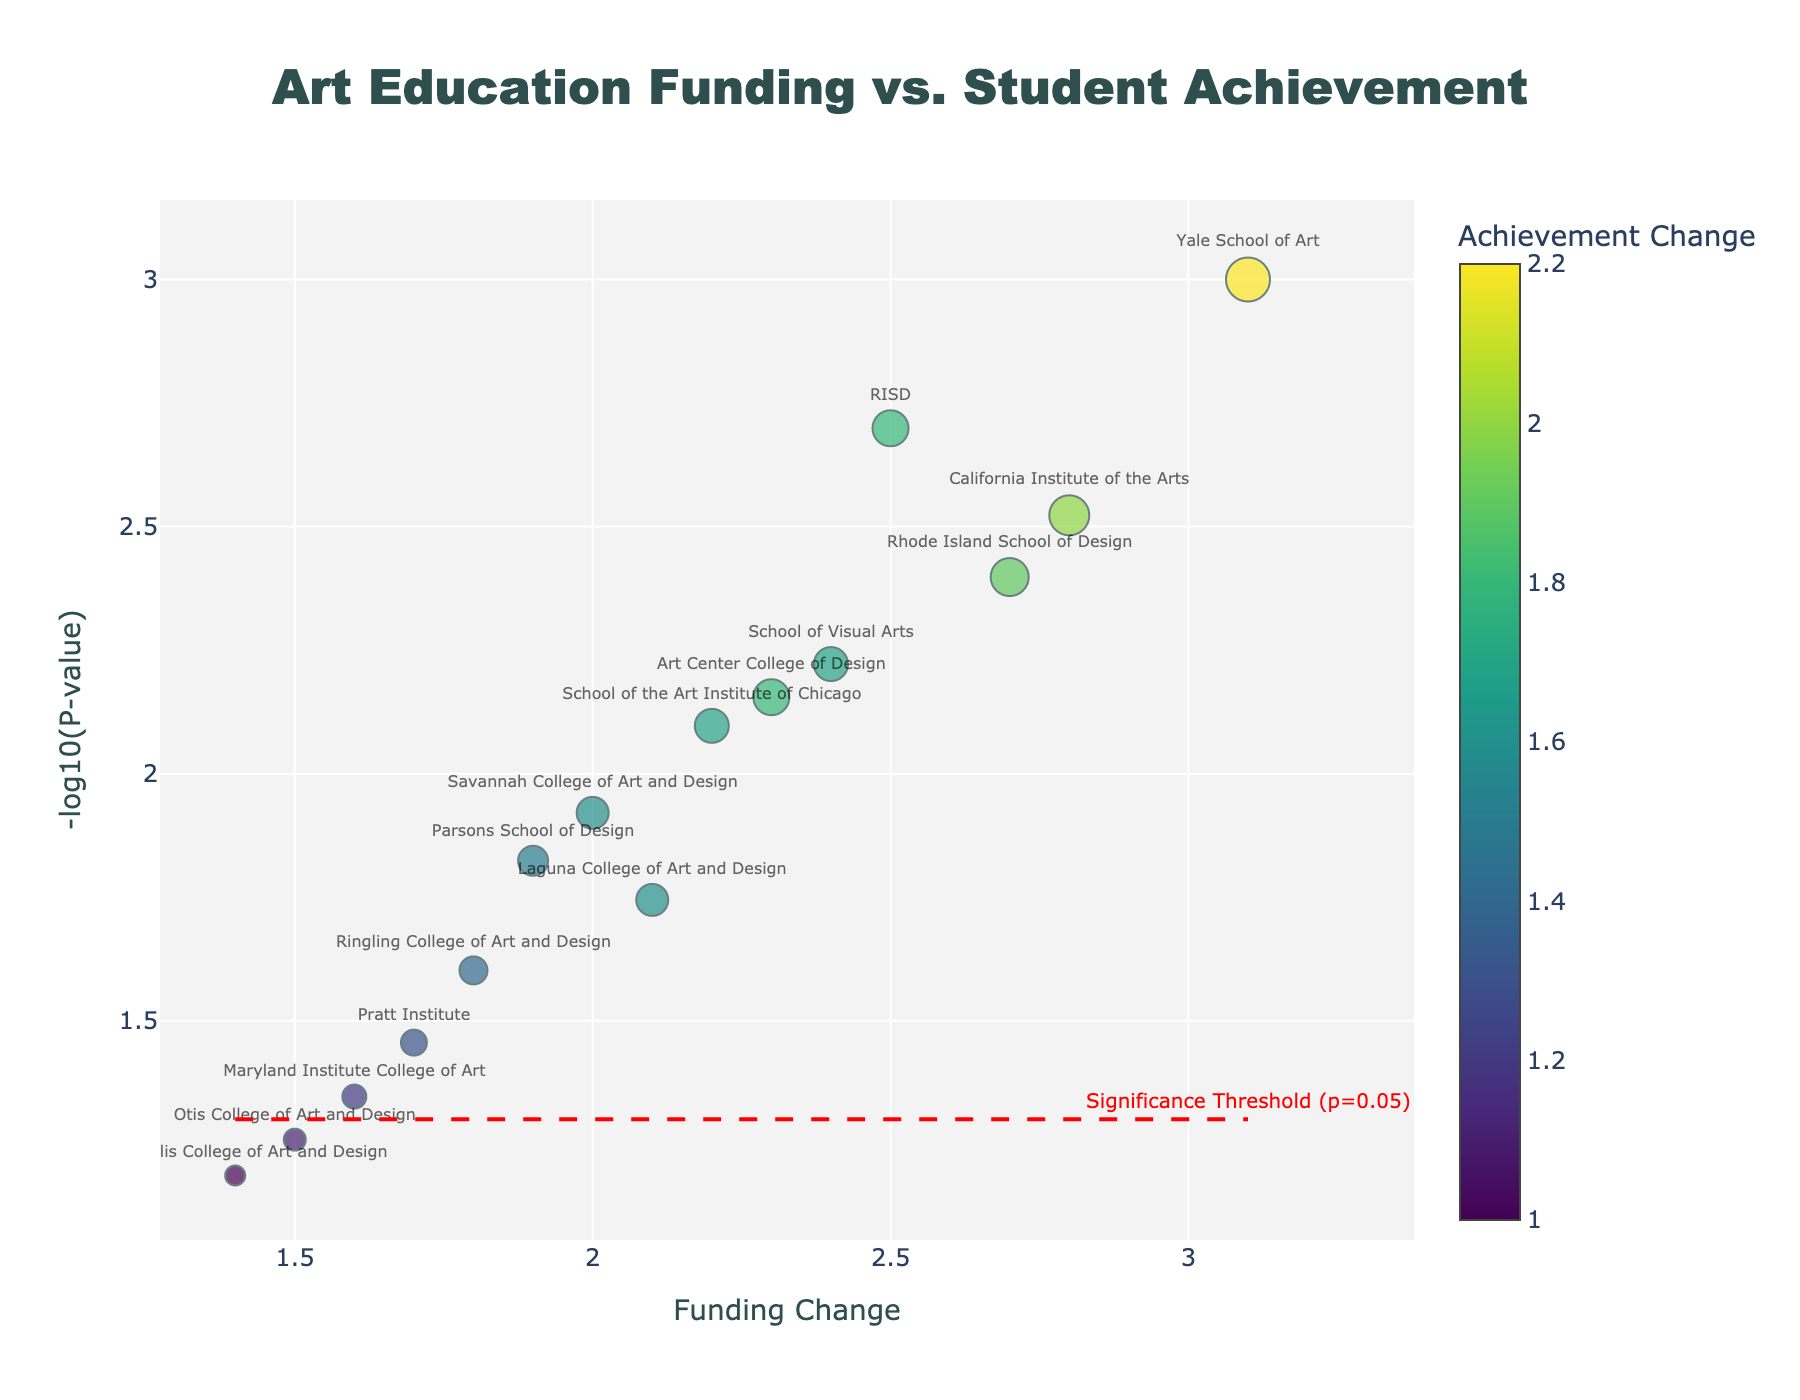What is the title of the figure? The title is located at the top of the figure in a larger, bold font. It summarizes the overall content. The title reads 'Art Education Funding vs. Student Achievement'.
Answer: Art Education Funding vs. Student Achievement Which school has the highest achievement change? Locate the data points and look at the size of the markers, which correlate to achievement change. The largest marker represents the highest achievement change. Yale School of Art is associated with a significant marker size, indicating the highest achievement change of 2.2.
Answer: Yale School of Art What does the red dashed line represent? The red dashed line is horizontal and runs across the plot, representing a -log10(p-value) level indicating the significance threshold. The annotation beside the line confirms that it marks the threshold where p = 0.05.
Answer: Significance Threshold (p=0.05) How many schools have funding changes greater than 2? Look at the x-axis, which represents funding changes. Counting the points positioned to the right of the x-axis value of 2, we observe that schools such as RISD, Yale School of Art, and California Institute of the Arts have funding changes greater than 2. There are a total of 6 schools with funding changes greater than 2.
Answer: 6 Which school has the lowest p-value? Locate the highest position on the y-axis because a lower p-value translates to a higher -log10(p-value). Yale School of Art is noticeably at the top, suggesting it has the lowest p-value of 0.001.
Answer: Yale School of Art Is there a general trend between funding change and achievement change among the schools? By observing the scatter points, especially the marker sizes and their positions on the x-axis, it appears that higher funding changes tend to coincide with larger marker sizes, implicating a general trend of higher achievement change with increased funding.
Answer: Yes, higher funding changes generally correlate with higher achievement changes What does the color of the markers represent? Each marker varies in color according to a colorscale shown on the right-hand side of the plot. This colorscale corresponds to the achievement change. The shades represent increasing achievements from dark blue to yellow.
Answer: Achievement Change Which school has the smallest achievement change among those with significant p-values? Identify markers below the red significance threshold line. Among these, the smallest marker signifies the smallest achievement change. The Maryland Institute College of Art, located near the significance line, notes an achievement change of 1.2, the smallest among significant p-values.
Answer: Maryland Institute College of Art What is the mean funding change of all schools? Sum up all the funding changes provided and divide by the number of schools (15). Calculations: (2.5 + 1.9 + 3.1 + 2.2 + 1.6 + 2.8 + 2.0 + 1.7 + 2.7 + 2.3 + 1.8 + 1.5 + 2.4 + 1.4 + 2.1) / 15 = 2.2 approx.
Answer: 2.2 What is the relationship between -log10(P-value) and P-value? The y-axis represents -log10(P-value), which inversely correlates with P-value. Lower p-values will provide higher -log10(P-value) values on the plot. For instance, Yale School of Art at the highest y-position signifies it has the smallest p-value (0.001).
Answer: Inverse correlation 